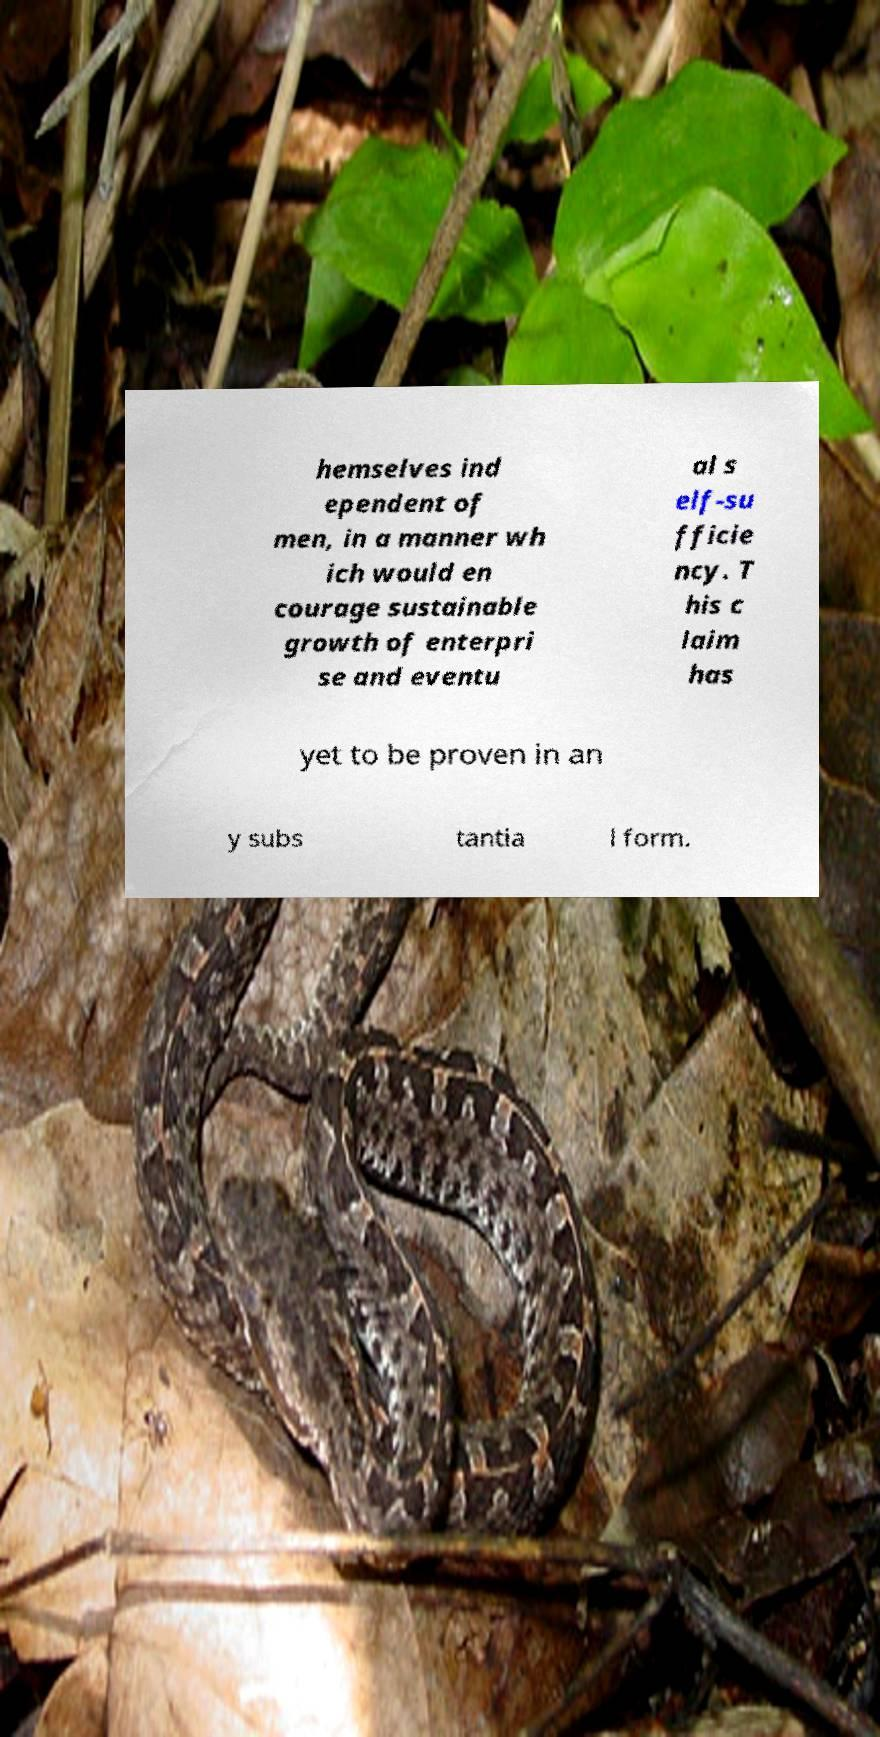Can you accurately transcribe the text from the provided image for me? hemselves ind ependent of men, in a manner wh ich would en courage sustainable growth of enterpri se and eventu al s elf-su fficie ncy. T his c laim has yet to be proven in an y subs tantia l form. 